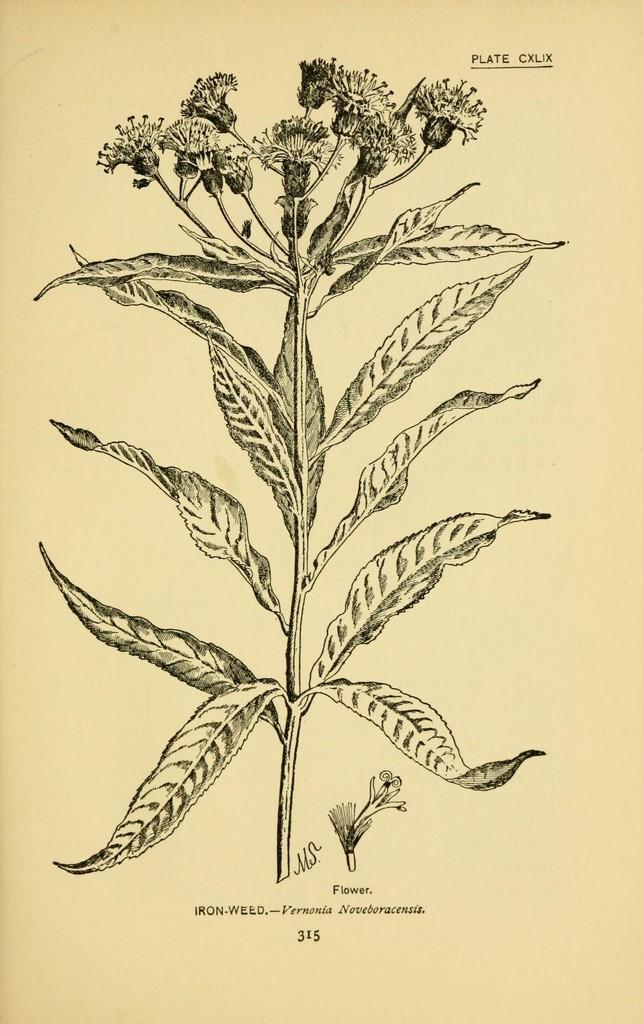Describe this image in one or two sentences. In the picture we can see the plant with flowers diagram on the paper. 